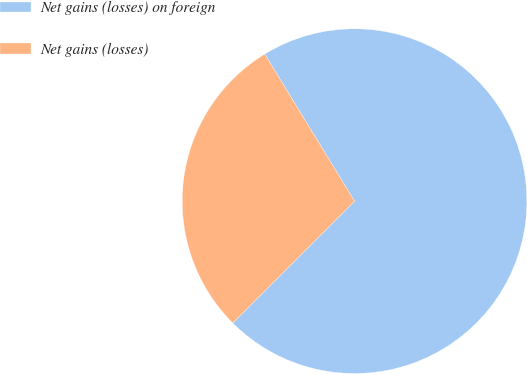<chart> <loc_0><loc_0><loc_500><loc_500><pie_chart><fcel>Net gains (losses) on foreign<fcel>Net gains (losses)<nl><fcel>71.23%<fcel>28.77%<nl></chart> 